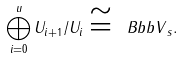Convert formula to latex. <formula><loc_0><loc_0><loc_500><loc_500>\bigoplus _ { i = 0 } ^ { u } U _ { i + 1 } / U _ { i } \cong { \ B b b V } _ { s } .</formula> 